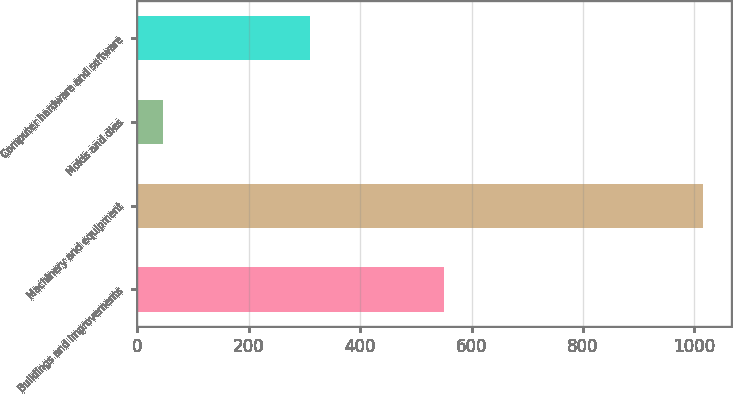Convert chart to OTSL. <chart><loc_0><loc_0><loc_500><loc_500><bar_chart><fcel>Buildings and improvements<fcel>Machinery and equipment<fcel>Molds and dies<fcel>Computer hardware and software<nl><fcel>550<fcel>1015<fcel>47<fcel>310<nl></chart> 